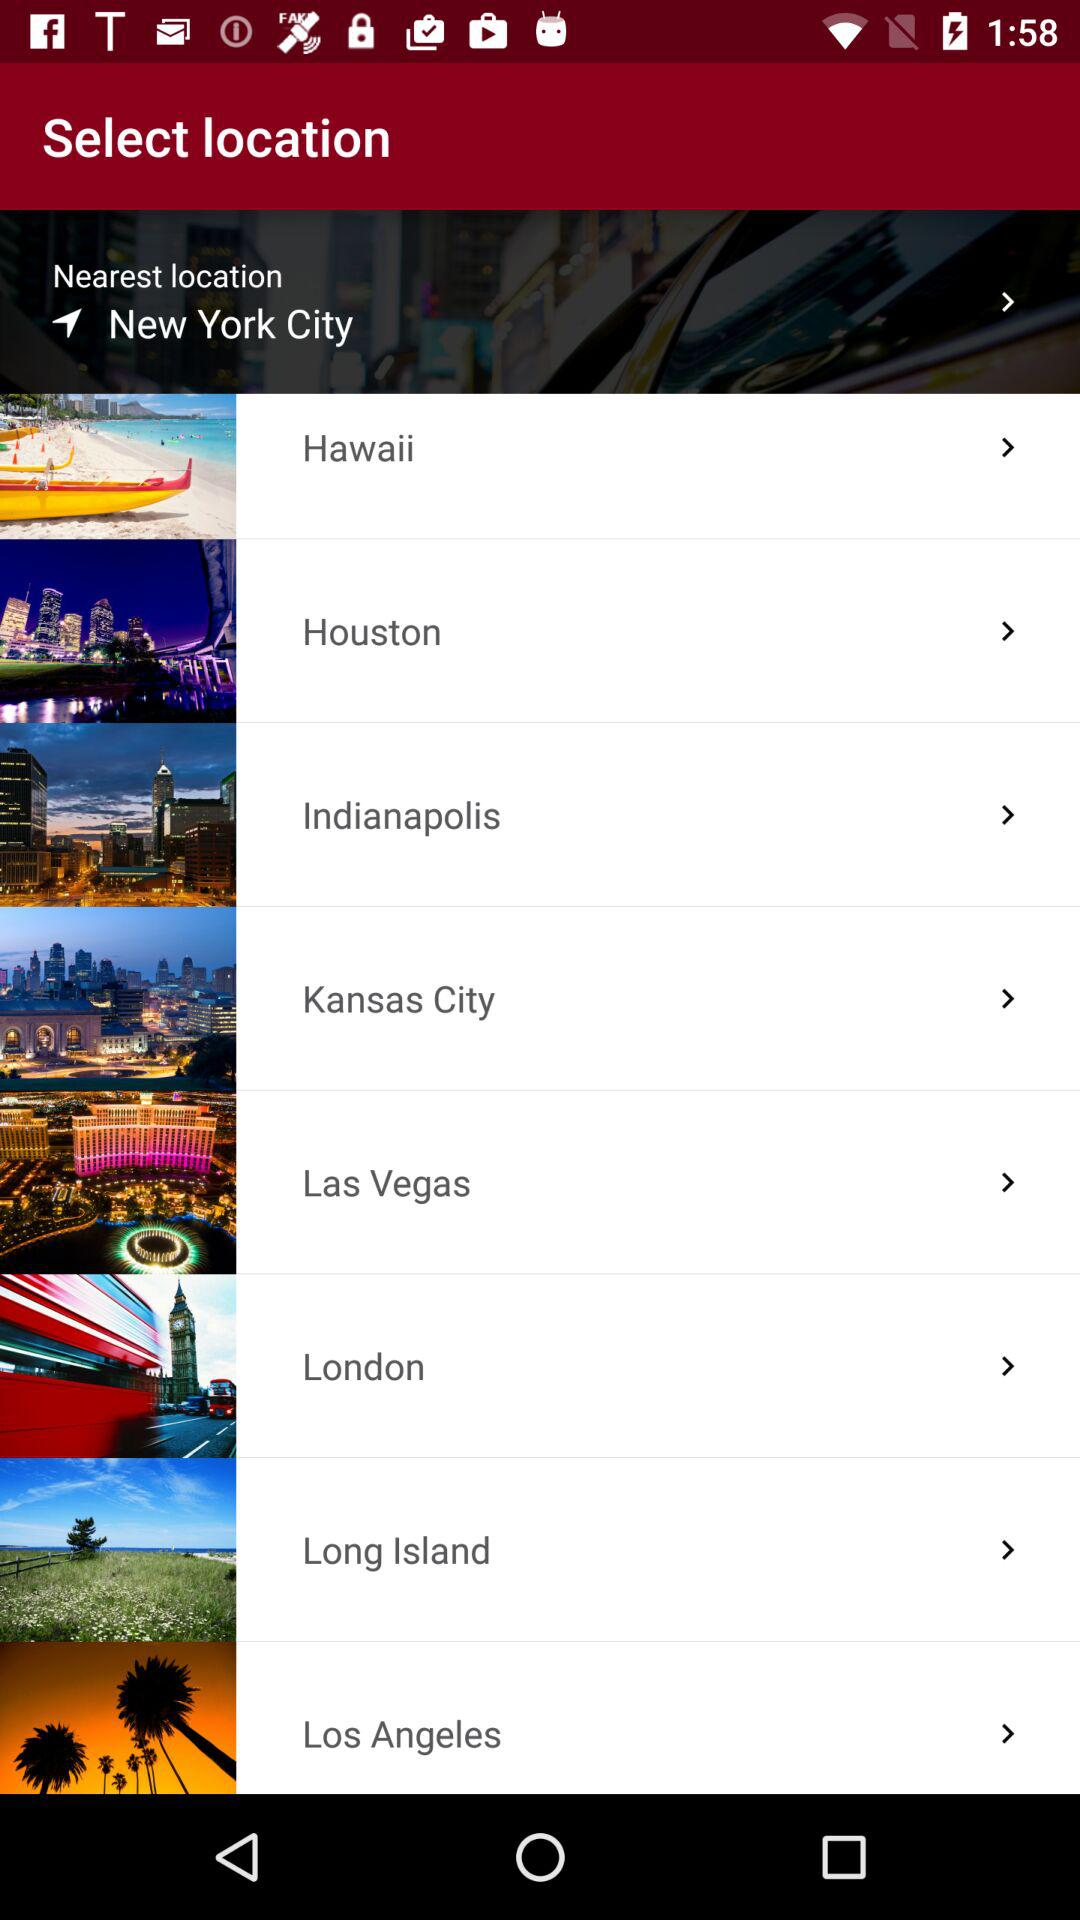What are the different nearest locations shown on the screen? The nearest location shown on the screen is New York City. 